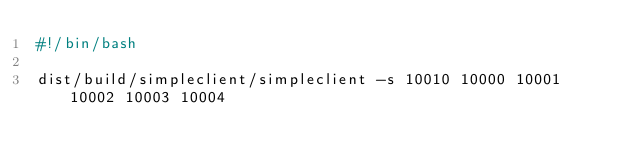<code> <loc_0><loc_0><loc_500><loc_500><_Bash_>#!/bin/bash

dist/build/simpleclient/simpleclient -s 10010 10000 10001 10002 10003 10004
</code> 